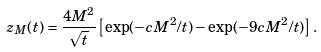Convert formula to latex. <formula><loc_0><loc_0><loc_500><loc_500>z _ { M } ( t ) = \frac { 4 M ^ { 2 } } { \sqrt { t } } \left [ \exp ( - { c M ^ { 2 } } / t ) - \exp ( - { 9 c M ^ { 2 } } / t ) \right ] .</formula> 